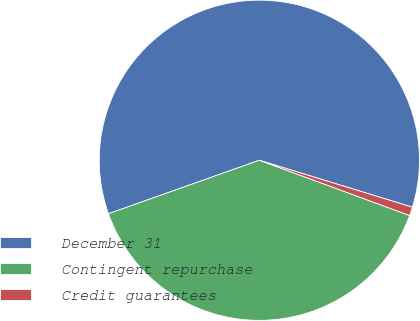Convert chart to OTSL. <chart><loc_0><loc_0><loc_500><loc_500><pie_chart><fcel>December 31<fcel>Contingent repurchase<fcel>Credit guarantees<nl><fcel>60.16%<fcel>38.97%<fcel>0.87%<nl></chart> 